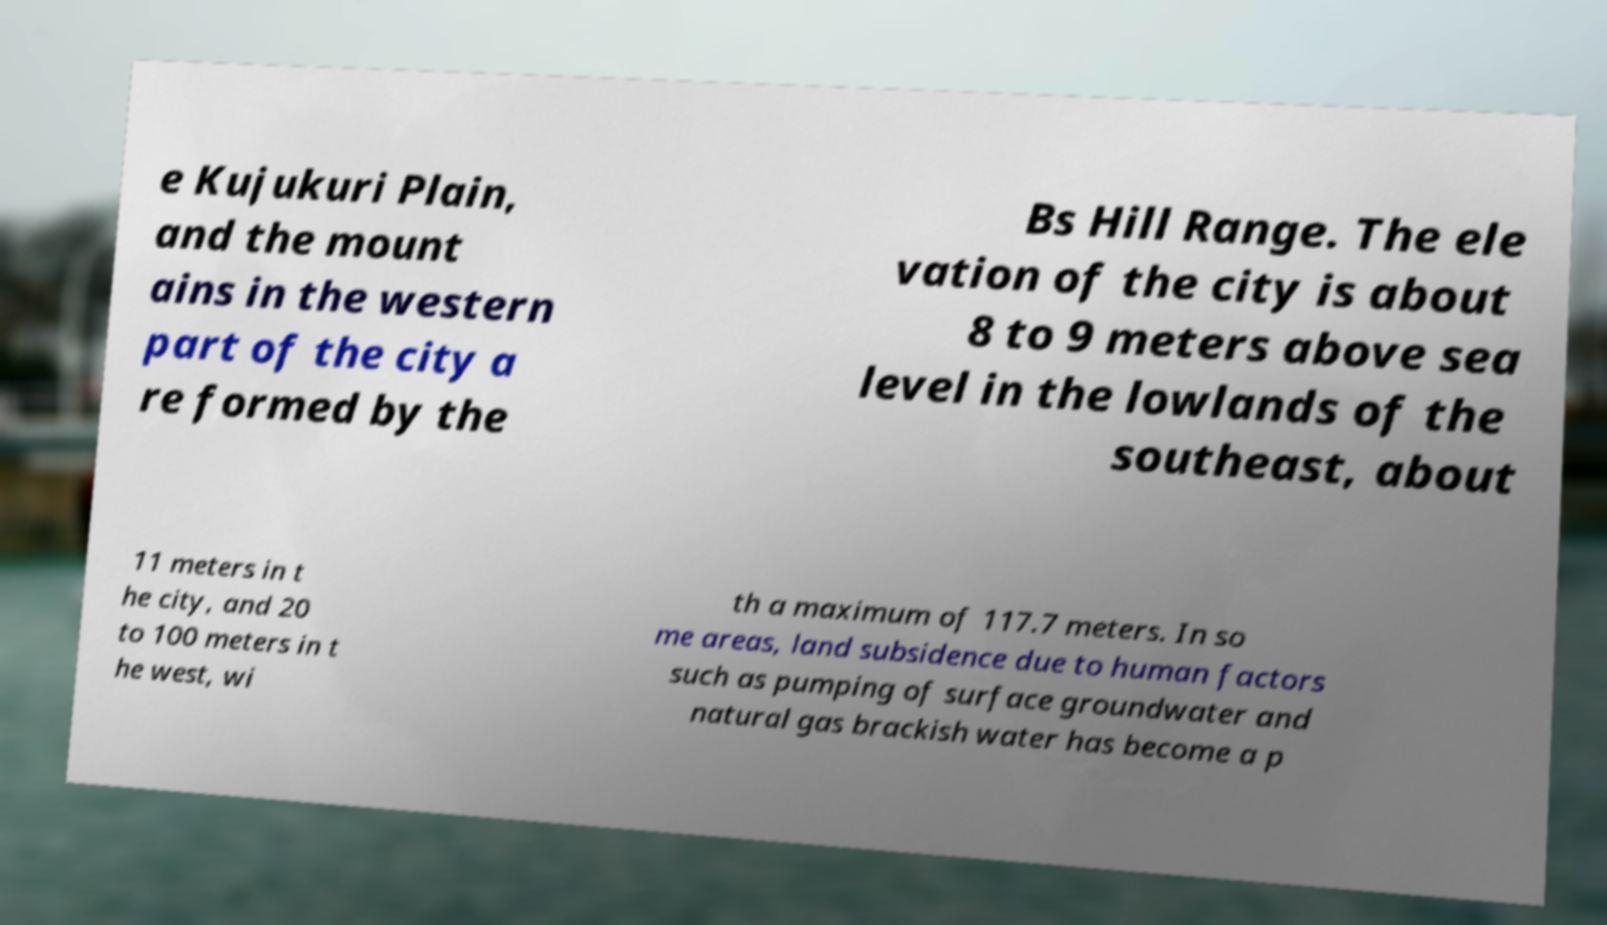Could you assist in decoding the text presented in this image and type it out clearly? e Kujukuri Plain, and the mount ains in the western part of the city a re formed by the Bs Hill Range. The ele vation of the city is about 8 to 9 meters above sea level in the lowlands of the southeast, about 11 meters in t he city, and 20 to 100 meters in t he west, wi th a maximum of 117.7 meters. In so me areas, land subsidence due to human factors such as pumping of surface groundwater and natural gas brackish water has become a p 